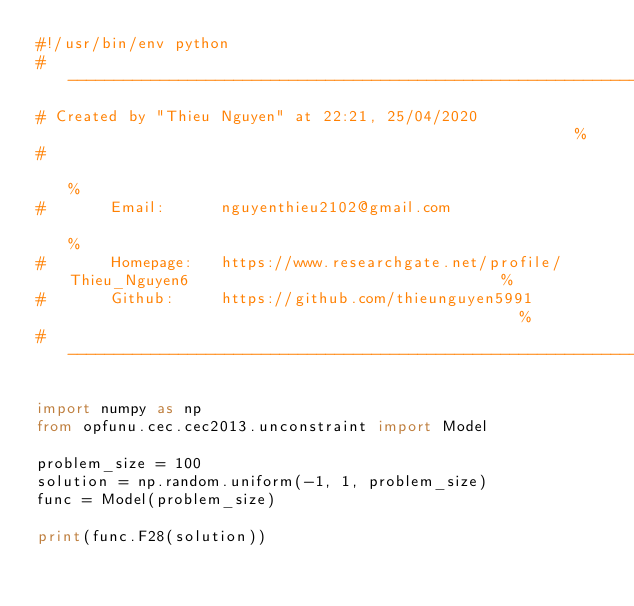<code> <loc_0><loc_0><loc_500><loc_500><_Python_>#!/usr/bin/env python
# ------------------------------------------------------------------------------------------------------%
# Created by "Thieu Nguyen" at 22:21, 25/04/2020                                                        %
#                                                                                                       %
#       Email:      nguyenthieu2102@gmail.com                                                           %
#       Homepage:   https://www.researchgate.net/profile/Thieu_Nguyen6                                  %
#       Github:     https://github.com/thieunguyen5991                                                  %
#-------------------------------------------------------------------------------------------------------%

import numpy as np
from opfunu.cec.cec2013.unconstraint import Model

problem_size = 100
solution = np.random.uniform(-1, 1, problem_size)
func = Model(problem_size)

print(func.F28(solution))
</code> 